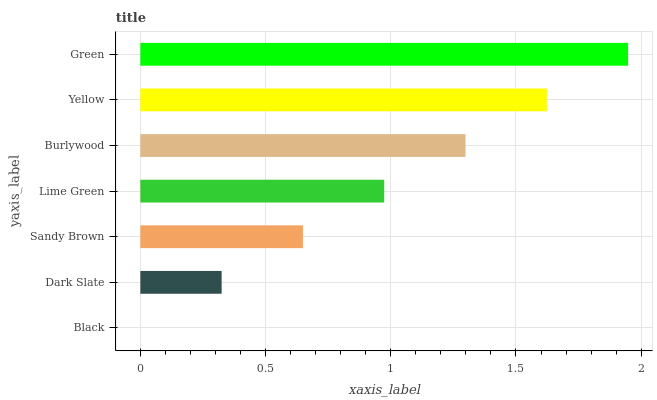Is Black the minimum?
Answer yes or no. Yes. Is Green the maximum?
Answer yes or no. Yes. Is Dark Slate the minimum?
Answer yes or no. No. Is Dark Slate the maximum?
Answer yes or no. No. Is Dark Slate greater than Black?
Answer yes or no. Yes. Is Black less than Dark Slate?
Answer yes or no. Yes. Is Black greater than Dark Slate?
Answer yes or no. No. Is Dark Slate less than Black?
Answer yes or no. No. Is Lime Green the high median?
Answer yes or no. Yes. Is Lime Green the low median?
Answer yes or no. Yes. Is Dark Slate the high median?
Answer yes or no. No. Is Black the low median?
Answer yes or no. No. 